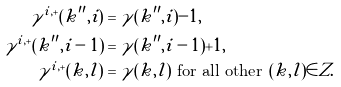<formula> <loc_0><loc_0><loc_500><loc_500>\gamma ^ { i , + } ( k ^ { \prime \prime } , i ) & = \gamma ( k ^ { \prime \prime } , i ) - 1 , \\ \gamma ^ { i , + } ( k ^ { \prime \prime } , i - 1 ) & = \gamma ( k ^ { \prime \prime } , i - 1 ) + 1 , \\ \gamma ^ { i , + } ( k , l ) & = \gamma ( k , l ) \text { for all other } ( k , l ) \in Z .</formula> 